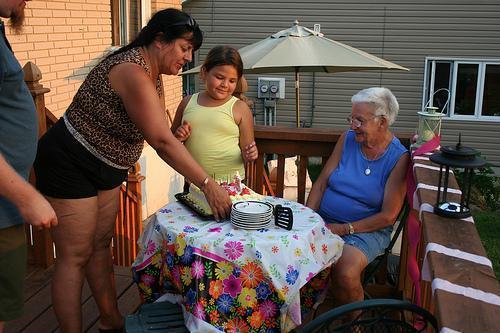How many people are visible in the photo?
Give a very brief answer. 4. How many men are in the photo?
Give a very brief answer. 1. 